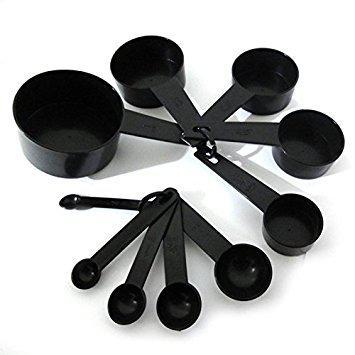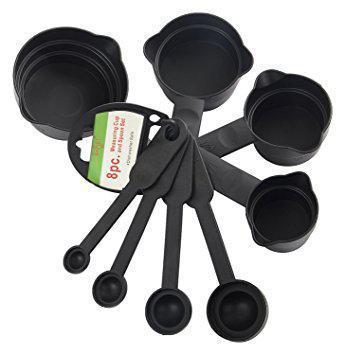The first image is the image on the left, the second image is the image on the right. Evaluate the accuracy of this statement regarding the images: "An image features measuring utensils with blue coloring.". Is it true? Answer yes or no. No. 